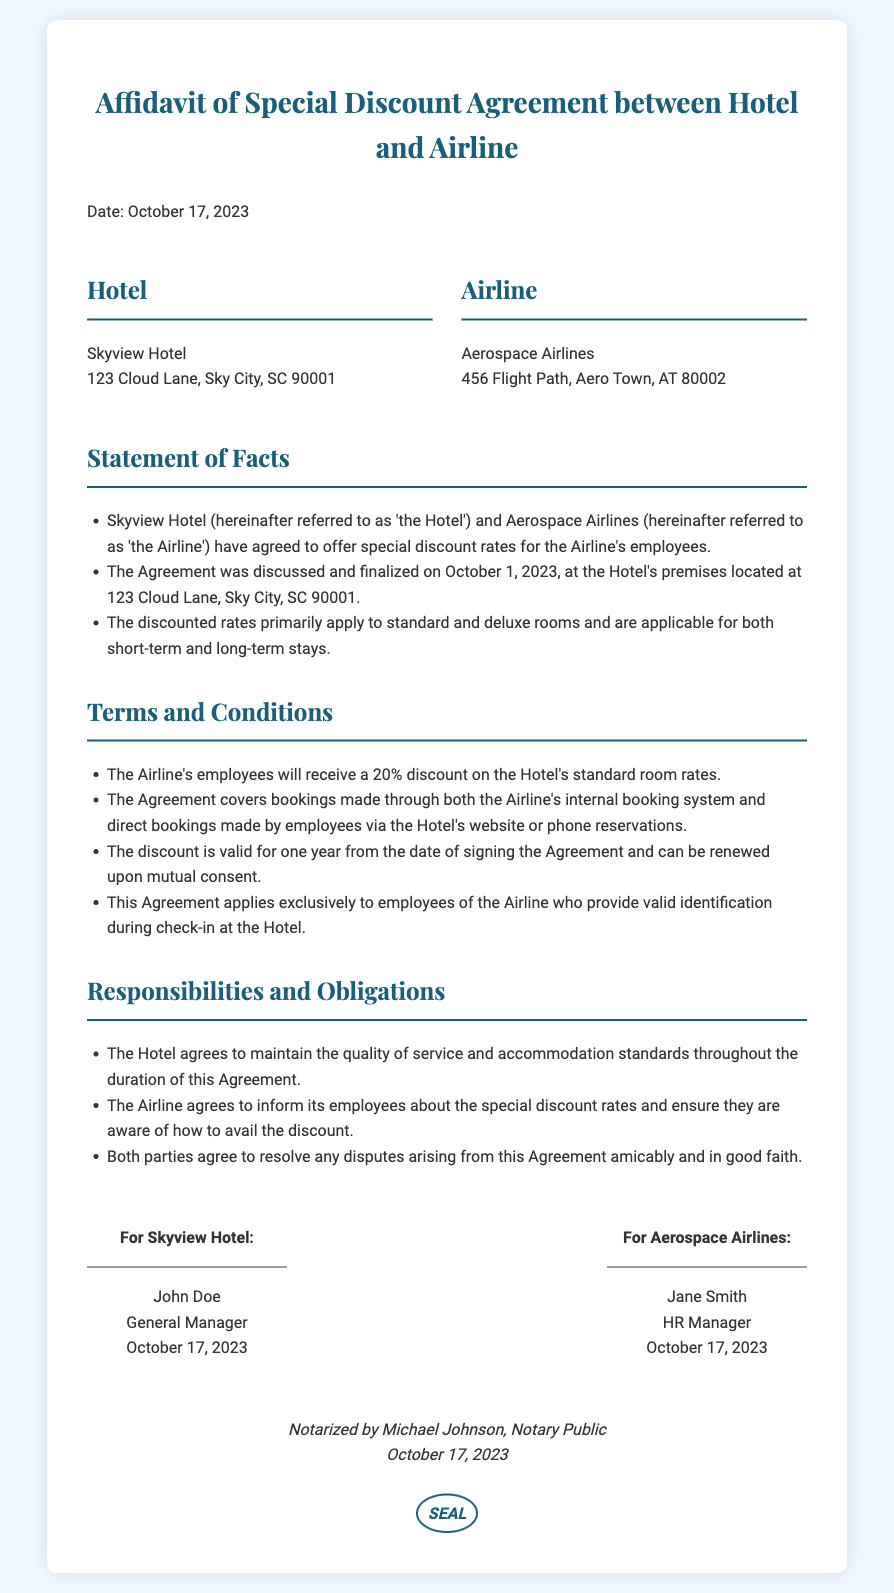What is the date of the agreement? The date of the agreement is stated at the top of the document as October 17, 2023.
Answer: October 17, 2023 Who is the General Manager of the Hotel? The General Manager of the Hotel is mentioned in the signature section as John Doe.
Answer: John Doe What discount percentage is offered to Airline employees? The agreement specifies that Airline employees will receive a 20% discount on standard room rates.
Answer: 20% What is the duration of the discount agreement? The document states that the discount is valid for one year from the date of signing the Agreement.
Answer: One year Where is the Skyview Hotel located? The address of the Skyview Hotel is listed in the document as 123 Cloud Lane, Sky City, SC 90001.
Answer: 123 Cloud Lane, Sky City, SC 90001 What are the responsibilities of the Airline in this agreement? The document states that the Airline agrees to inform its employees about the special discount rates.
Answer: Inform employees Who notarized the affidavit? The notarization is performed by a Notary Public mentioned as Michael Johnson.
Answer: Michael Johnson When was the agreement finalized? The document indicates that the Agreement was discussed and finalized on October 1, 2023.
Answer: October 1, 2023 What is the Hotel's commitment regarding service quality? The Hotel agrees to maintain the quality of service and accommodation standards throughout the duration of this Agreement.
Answer: Maintain quality of service 